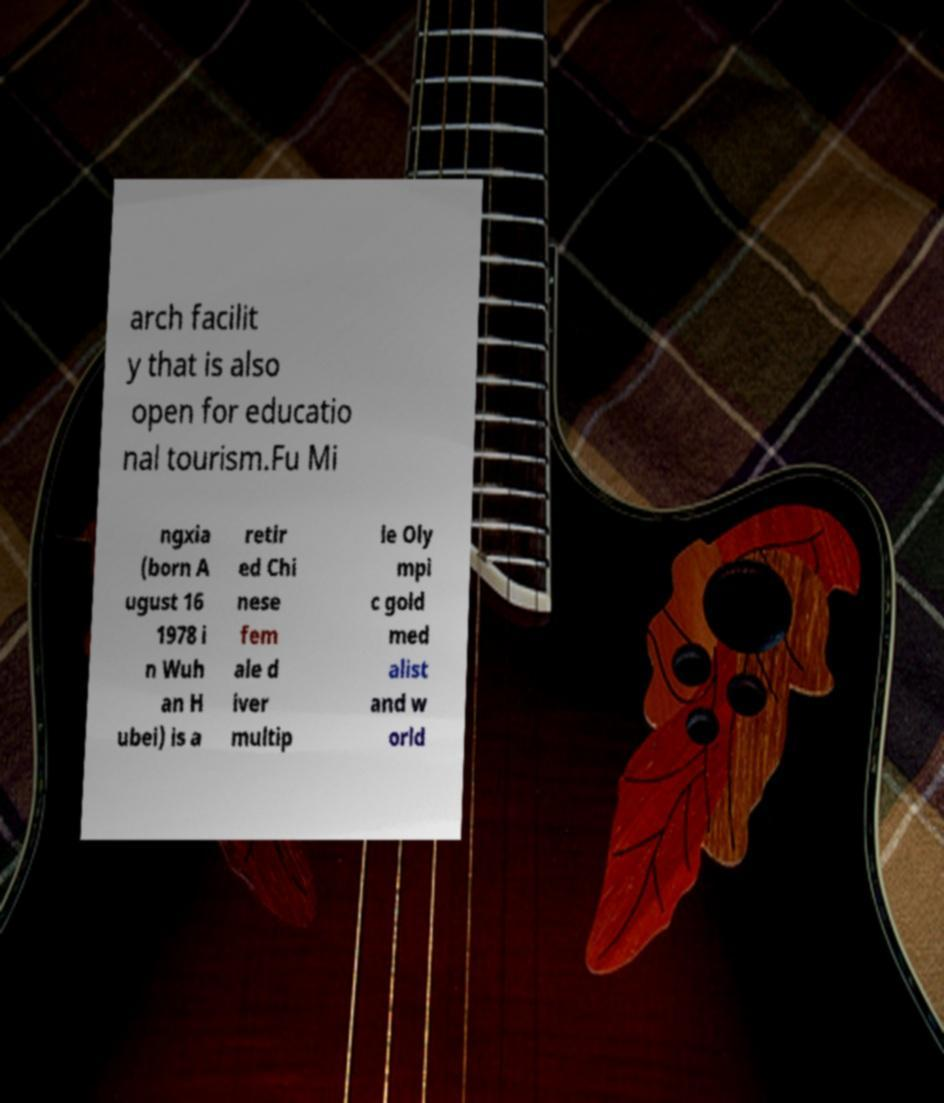Could you extract and type out the text from this image? arch facilit y that is also open for educatio nal tourism.Fu Mi ngxia (born A ugust 16 1978 i n Wuh an H ubei) is a retir ed Chi nese fem ale d iver multip le Oly mpi c gold med alist and w orld 